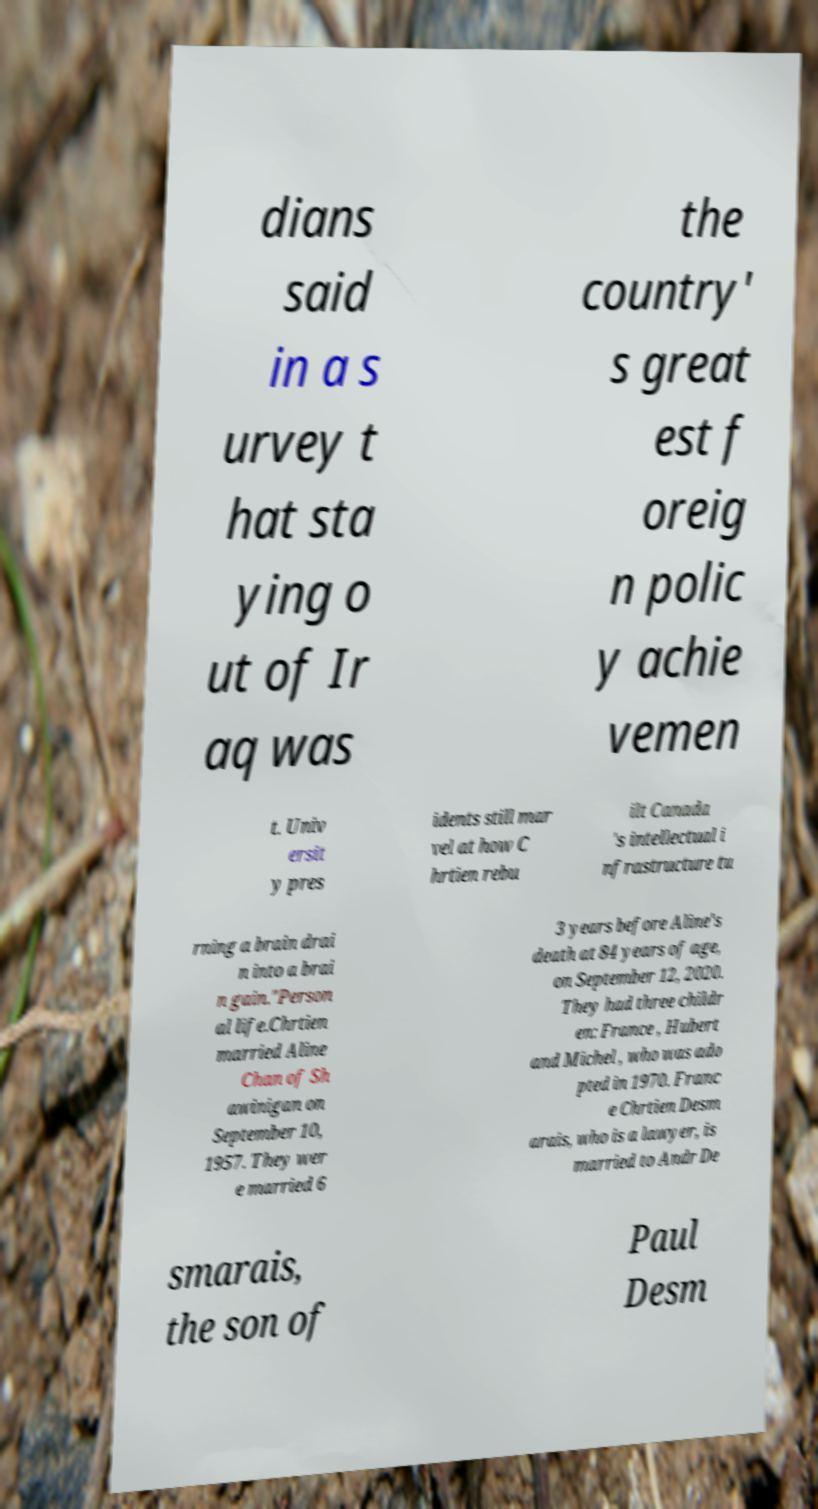I need the written content from this picture converted into text. Can you do that? dians said in a s urvey t hat sta ying o ut of Ir aq was the country' s great est f oreig n polic y achie vemen t. Univ ersit y pres idents still mar vel at how C hrtien rebu ilt Canada 's intellectual i nfrastructure tu rning a brain drai n into a brai n gain."Person al life.Chrtien married Aline Chan of Sh awinigan on September 10, 1957. They wer e married 6 3 years before Aline's death at 84 years of age, on September 12, 2020. They had three childr en: France , Hubert and Michel , who was ado pted in 1970. Franc e Chrtien Desm arais, who is a lawyer, is married to Andr De smarais, the son of Paul Desm 